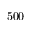Convert formula to latex. <formula><loc_0><loc_0><loc_500><loc_500>5 0 0</formula> 